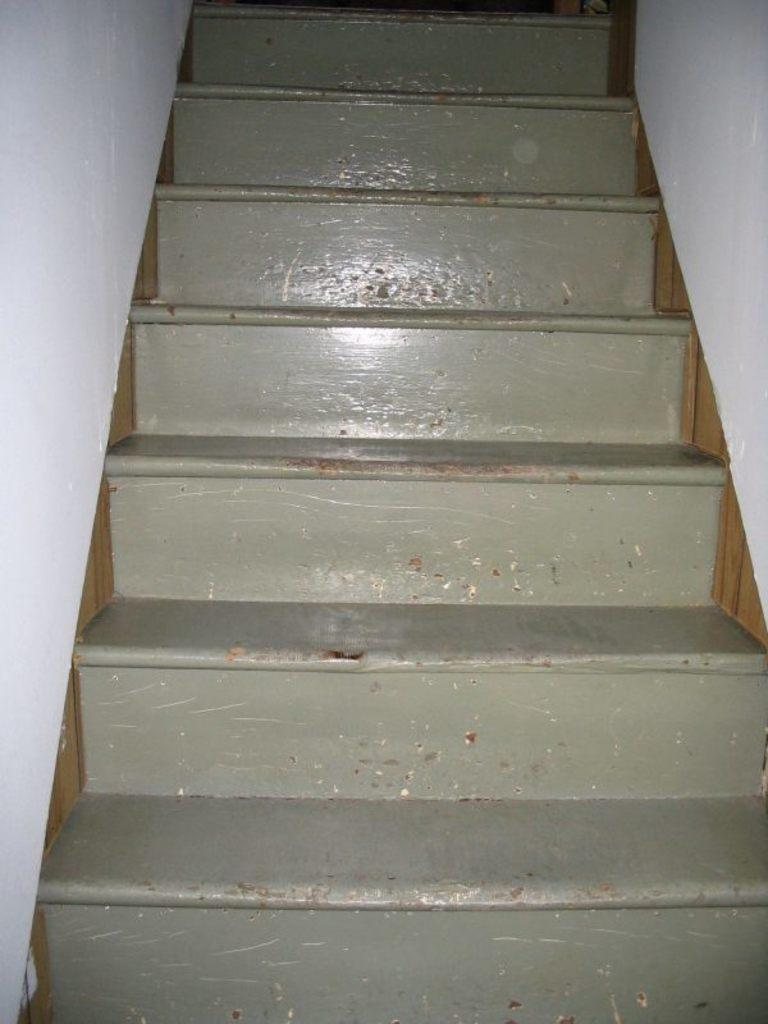What is the focus of the image? The image is zoomed in on a specific area. What can be seen in the center of the image? There are stairs in the center of the image. What color are the walls on the right side of the image? The walls on the right side of the image are white. What color are the walls on the left side of the image? The walls on the left side of the image are also white. What type of wax is being used to answer questions in the image? There is no wax or questions being answered in the image; it features stairs and white walls. 